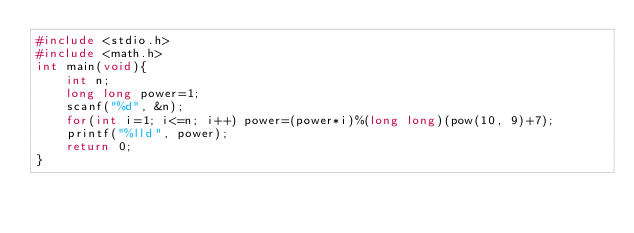<code> <loc_0><loc_0><loc_500><loc_500><_C_>#include <stdio.h>
#include <math.h>
int main(void){
    int n;
    long long power=1;
    scanf("%d", &n);
    for(int i=1; i<=n; i++) power=(power*i)%(long long)(pow(10, 9)+7);
    printf("%lld", power);
    return 0;
}</code> 